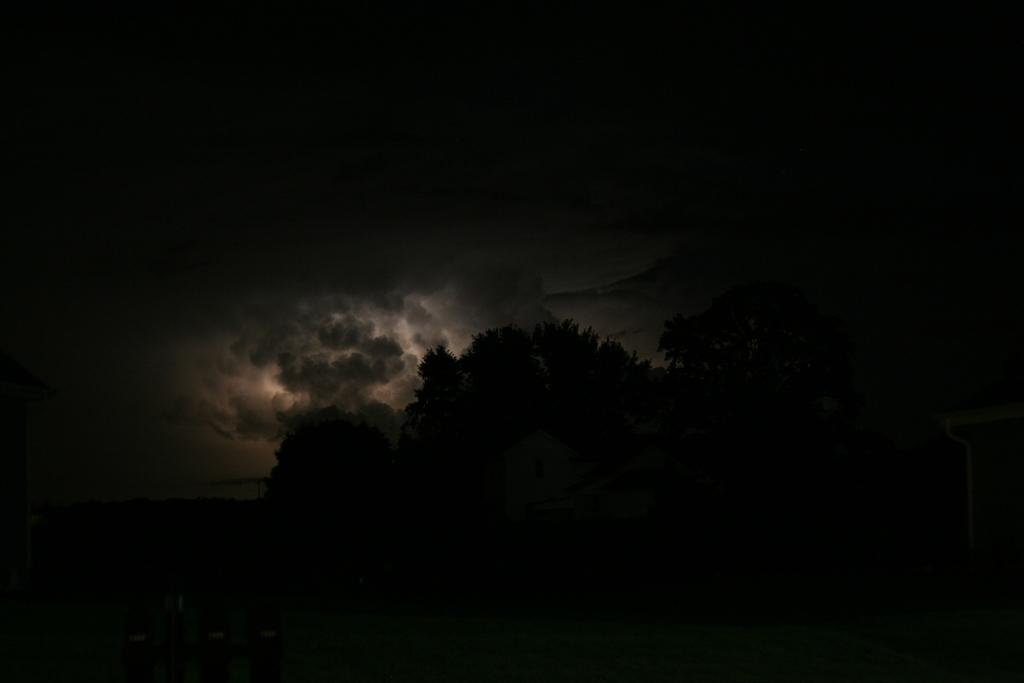What is the overall lighting condition in the image? The image has a dark view. What can be seen in the middle of the picture? There are trees and houses in the middle of the picture. What is visible in the background of the image? The sky is visible in the background of the image. How many birds are perched on the neck of the tree in the image? There are no birds present in the image, and trees do not have necks. What type of oven can be seen in the background of the image? There is no oven present in the image; the background features the sky. 